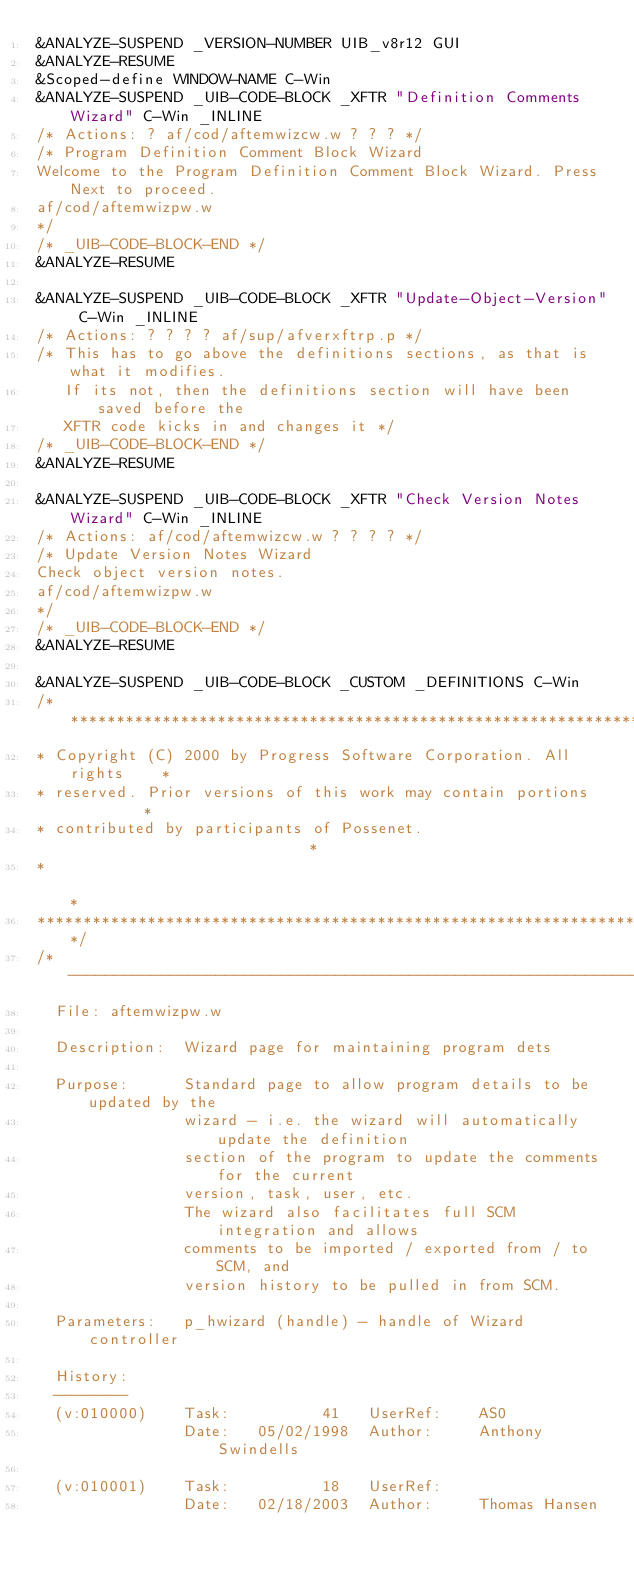<code> <loc_0><loc_0><loc_500><loc_500><_C_>&ANALYZE-SUSPEND _VERSION-NUMBER UIB_v8r12 GUI
&ANALYZE-RESUME
&Scoped-define WINDOW-NAME C-Win
&ANALYZE-SUSPEND _UIB-CODE-BLOCK _XFTR "Definition Comments Wizard" C-Win _INLINE
/* Actions: ? af/cod/aftemwizcw.w ? ? ? */
/* Program Definition Comment Block Wizard
Welcome to the Program Definition Comment Block Wizard. Press Next to proceed.
af/cod/aftemwizpw.w
*/
/* _UIB-CODE-BLOCK-END */
&ANALYZE-RESUME

&ANALYZE-SUSPEND _UIB-CODE-BLOCK _XFTR "Update-Object-Version" C-Win _INLINE
/* Actions: ? ? ? ? af/sup/afverxftrp.p */
/* This has to go above the definitions sections, as that is what it modifies.
   If its not, then the definitions section will have been saved before the
   XFTR code kicks in and changes it */
/* _UIB-CODE-BLOCK-END */
&ANALYZE-RESUME

&ANALYZE-SUSPEND _UIB-CODE-BLOCK _XFTR "Check Version Notes Wizard" C-Win _INLINE
/* Actions: af/cod/aftemwizcw.w ? ? ? ? */
/* Update Version Notes Wizard
Check object version notes.
af/cod/aftemwizpw.w
*/
/* _UIB-CODE-BLOCK-END */
&ANALYZE-RESUME

&ANALYZE-SUSPEND _UIB-CODE-BLOCK _CUSTOM _DEFINITIONS C-Win 
/*********************************************************************
* Copyright (C) 2000 by Progress Software Corporation. All rights    *
* reserved. Prior versions of this work may contain portions         *
* contributed by participants of Possenet.                           *
*                                                                    *
*********************************************************************/
/*---------------------------------------------------------------------------------
  File: aftemwizpw.w
  
  Description:  Wizard page for maintaining program dets

  Purpose:      Standard page to allow program details to be updated by the
                wizard - i.e. the wizard will automatically update the definition
                section of the program to update the comments for the current
                version, task, user, etc.
                The wizard also facilitates full SCM integration and allows
                comments to be imported / exported from / to SCM, and
                version history to be pulled in from SCM.

  Parameters:   p_hwizard (handle) - handle of Wizard controller

  History:
  --------
  (v:010000)    Task:          41   UserRef:    AS0
                Date:   05/02/1998  Author:     Anthony Swindells

  (v:010001)    Task:          18   UserRef:    
                Date:   02/18/2003  Author:     Thomas Hansen
</code> 